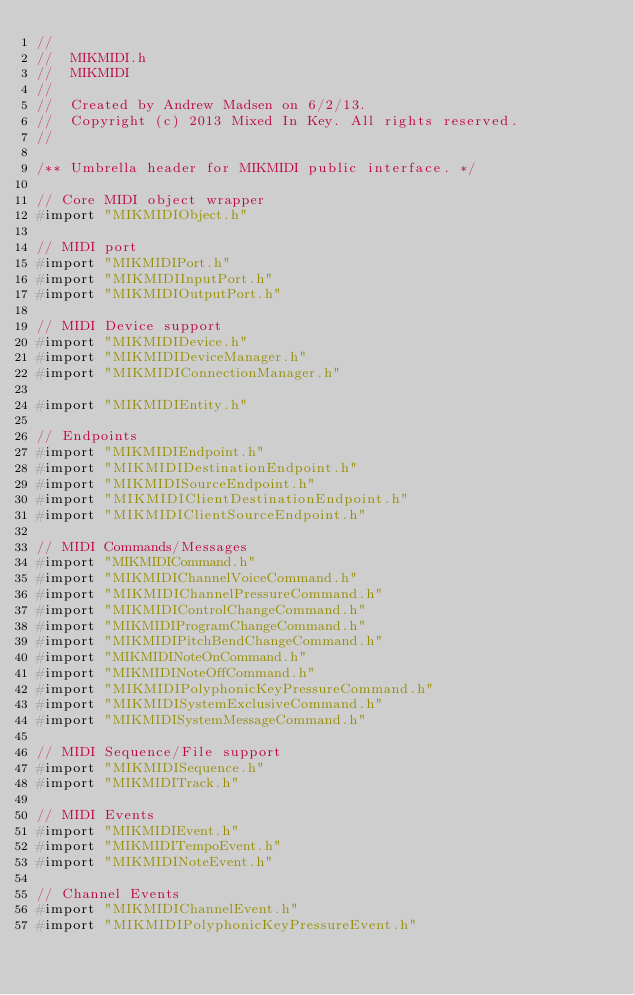Convert code to text. <code><loc_0><loc_0><loc_500><loc_500><_C_>//
//  MIKMIDI.h
//  MIKMIDI
//
//  Created by Andrew Madsen on 6/2/13.
//  Copyright (c) 2013 Mixed In Key. All rights reserved.
//

/** Umbrella header for MIKMIDI public interface. */

// Core MIDI object wrapper
#import "MIKMIDIObject.h"

// MIDI port
#import "MIKMIDIPort.h"
#import "MIKMIDIInputPort.h"
#import "MIKMIDIOutputPort.h"

// MIDI Device support
#import "MIKMIDIDevice.h"
#import "MIKMIDIDeviceManager.h"
#import "MIKMIDIConnectionManager.h"

#import "MIKMIDIEntity.h"

// Endpoints
#import "MIKMIDIEndpoint.h"
#import "MIKMIDIDestinationEndpoint.h"
#import "MIKMIDISourceEndpoint.h"
#import "MIKMIDIClientDestinationEndpoint.h"
#import "MIKMIDIClientSourceEndpoint.h"

// MIDI Commands/Messages
#import "MIKMIDICommand.h"
#import "MIKMIDIChannelVoiceCommand.h"
#import "MIKMIDIChannelPressureCommand.h"
#import "MIKMIDIControlChangeCommand.h"
#import "MIKMIDIProgramChangeCommand.h"
#import "MIKMIDIPitchBendChangeCommand.h"
#import "MIKMIDINoteOnCommand.h"
#import "MIKMIDINoteOffCommand.h"
#import "MIKMIDIPolyphonicKeyPressureCommand.h"
#import "MIKMIDISystemExclusiveCommand.h"
#import "MIKMIDISystemMessageCommand.h"

// MIDI Sequence/File support
#import "MIKMIDISequence.h"
#import "MIKMIDITrack.h"

// MIDI Events
#import "MIKMIDIEvent.h"
#import "MIKMIDITempoEvent.h"
#import "MIKMIDINoteEvent.h"

// Channel Events
#import "MIKMIDIChannelEvent.h"
#import "MIKMIDIPolyphonicKeyPressureEvent.h"</code> 